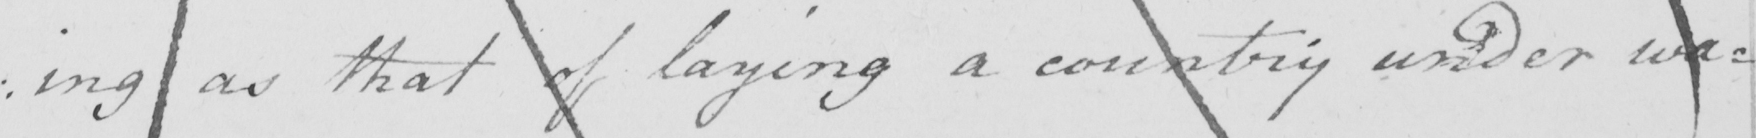What does this handwritten line say? : ing as that of laying a country under wa= 